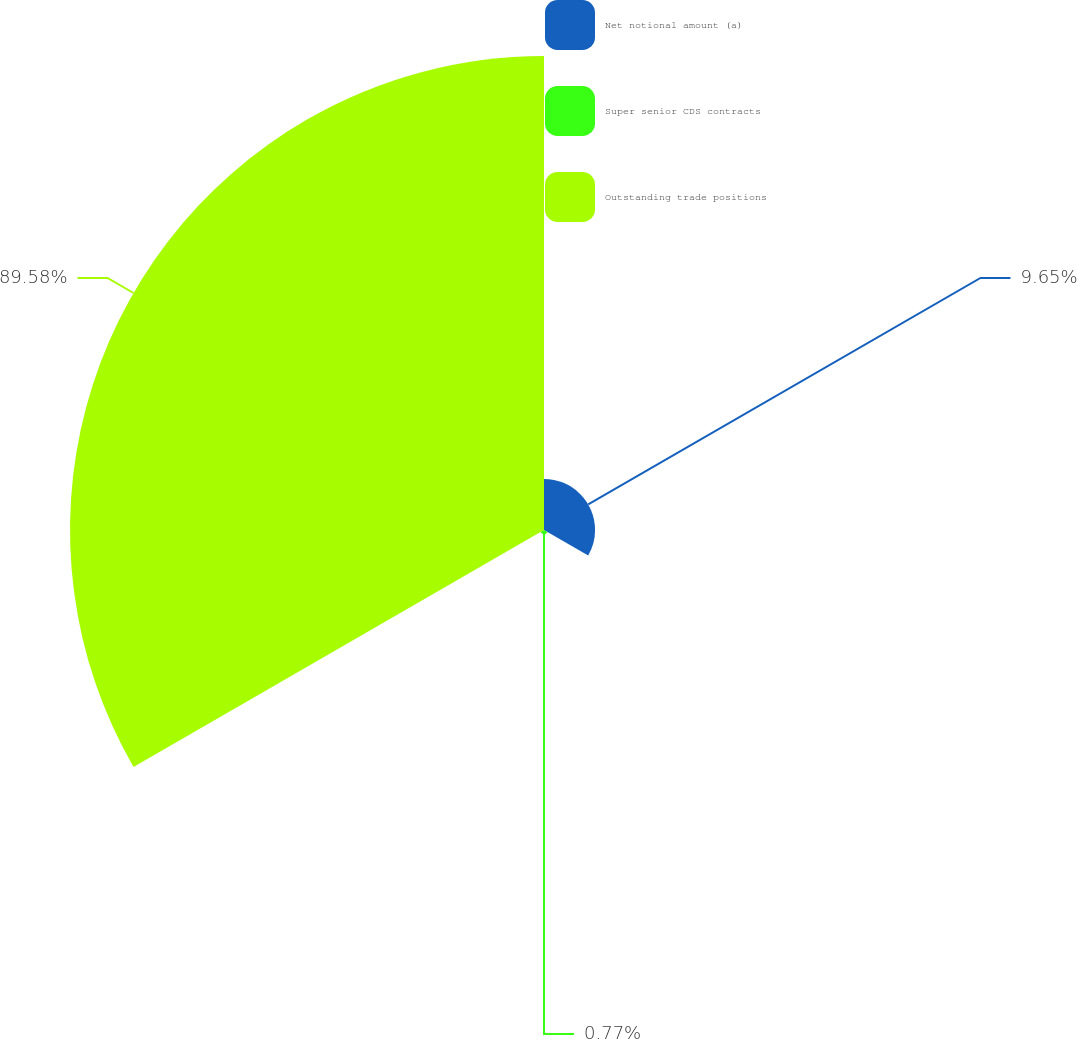Convert chart. <chart><loc_0><loc_0><loc_500><loc_500><pie_chart><fcel>Net notional amount (a)<fcel>Super senior CDS contracts<fcel>Outstanding trade positions<nl><fcel>9.65%<fcel>0.77%<fcel>89.58%<nl></chart> 